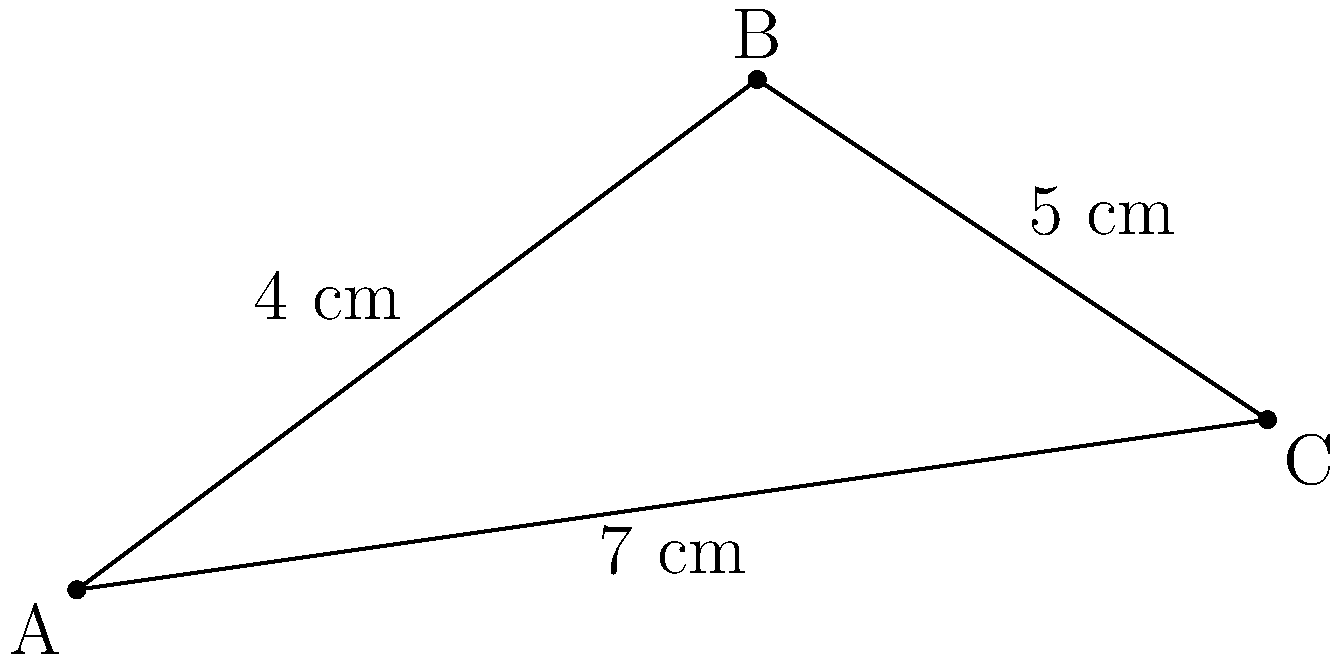A crochet enthusiast is working on a triangular shawl project. The shawl's shape is represented by triangle ABC in the coordinate plane, where A(0,0), B(4,3), and C(7,1) are the vertices. Calculate the total length of yarn needed to crochet along the edges of this shawl, rounded to the nearest centimeter. To find the total length of yarn needed, we need to calculate the perimeter of the triangle. We'll use the distance formula to find the length of each side:

1. Length of AB:
   $$d = \sqrt{(x_2-x_1)^2 + (y_2-y_1)^2}$$
   $$AB = \sqrt{(4-0)^2 + (3-0)^2} = \sqrt{16 + 9} = \sqrt{25} = 5\text{ cm}$$

2. Length of BC:
   $$BC = \sqrt{(7-4)^2 + (1-3)^2} = \sqrt{9 + 4} = \sqrt{13} \approx 3.61\text{ cm}$$

3. Length of AC:
   $$AC = \sqrt{(7-0)^2 + (1-0)^2} = \sqrt{49 + 1} = \sqrt{50} \approx 7.07\text{ cm}$$

4. Total length:
   $$\text{Total} = AB + BC + AC = 5 + 3.61 + 7.07 = 15.68\text{ cm}$$

5. Rounding to the nearest centimeter:
   $$15.68\text{ cm} \approx 16\text{ cm}$$

Therefore, the total length of yarn needed is approximately 16 cm.
Answer: 16 cm 